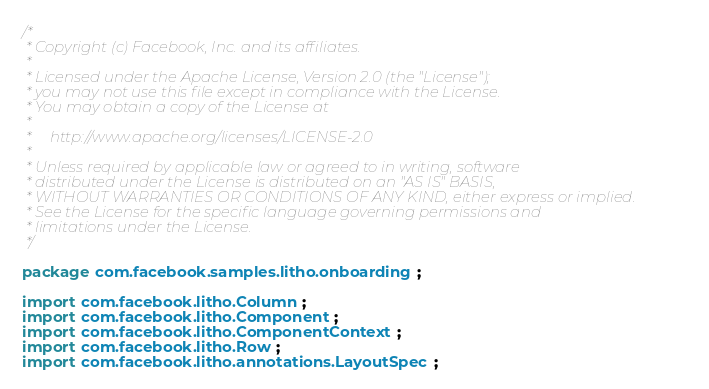<code> <loc_0><loc_0><loc_500><loc_500><_Java_>/*
 * Copyright (c) Facebook, Inc. and its affiliates.
 *
 * Licensed under the Apache License, Version 2.0 (the "License");
 * you may not use this file except in compliance with the License.
 * You may obtain a copy of the License at
 *
 *     http://www.apache.org/licenses/LICENSE-2.0
 *
 * Unless required by applicable law or agreed to in writing, software
 * distributed under the License is distributed on an "AS IS" BASIS,
 * WITHOUT WARRANTIES OR CONDITIONS OF ANY KIND, either express or implied.
 * See the License for the specific language governing permissions and
 * limitations under the License.
 */

package com.facebook.samples.litho.onboarding;

import com.facebook.litho.Column;
import com.facebook.litho.Component;
import com.facebook.litho.ComponentContext;
import com.facebook.litho.Row;
import com.facebook.litho.annotations.LayoutSpec;</code> 